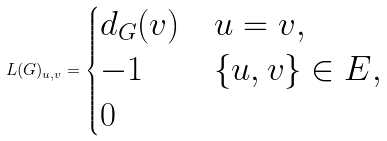Convert formula to latex. <formula><loc_0><loc_0><loc_500><loc_500>L ( G ) _ { u , v } = \begin{cases} d _ { G } ( v ) & u = v , \\ - 1 & \{ u , v \} \in E , \\ 0 & \end{cases}</formula> 